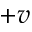Convert formula to latex. <formula><loc_0><loc_0><loc_500><loc_500>+ v</formula> 